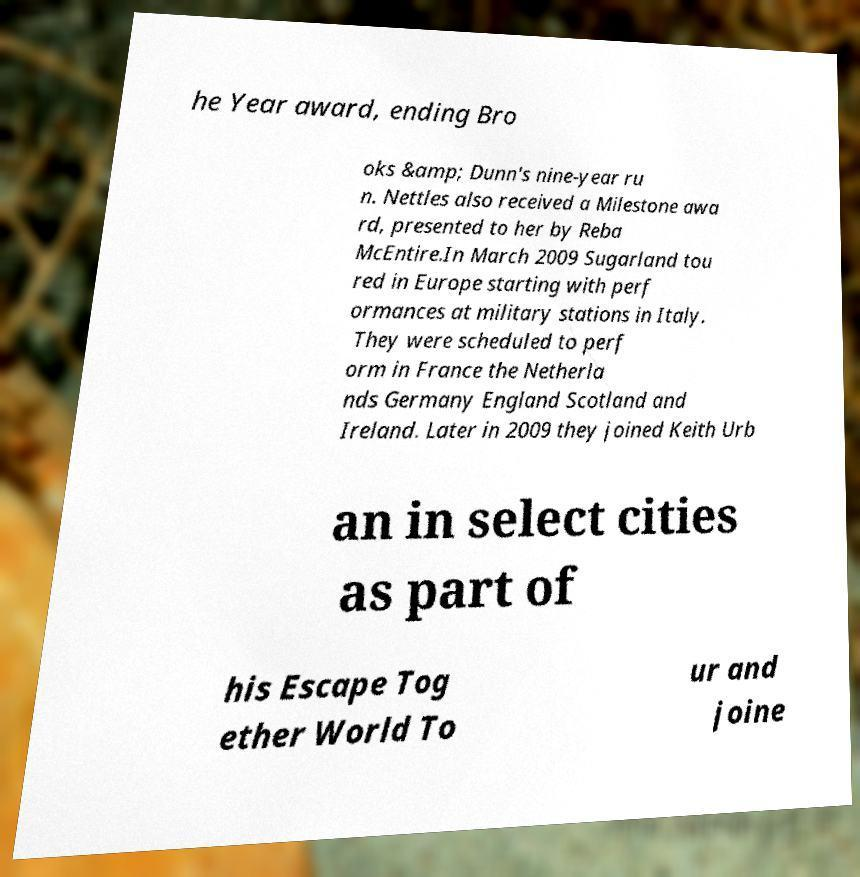Could you extract and type out the text from this image? he Year award, ending Bro oks &amp; Dunn's nine-year ru n. Nettles also received a Milestone awa rd, presented to her by Reba McEntire.In March 2009 Sugarland tou red in Europe starting with perf ormances at military stations in Italy. They were scheduled to perf orm in France the Netherla nds Germany England Scotland and Ireland. Later in 2009 they joined Keith Urb an in select cities as part of his Escape Tog ether World To ur and joine 